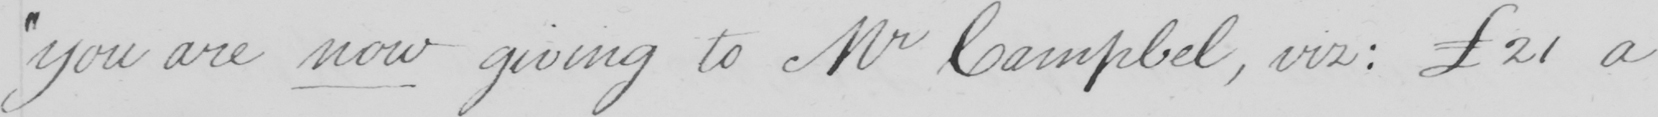What text is written in this handwritten line? " you are now giving to Mr Campbel , viz :  21 a 